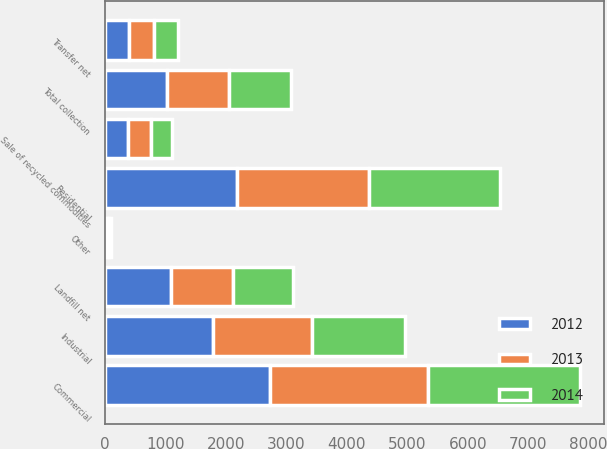<chart> <loc_0><loc_0><loc_500><loc_500><stacked_bar_chart><ecel><fcel>Residential<fcel>Commercial<fcel>Industrial<fcel>Other<fcel>Total collection<fcel>Transfer net<fcel>Landfill net<fcel>Sale of recycled commodities<nl><fcel>2012<fcel>2193.6<fcel>2723.3<fcel>1784<fcel>37.2<fcel>1025<fcel>408.2<fcel>1086.4<fcel>390.8<nl><fcel>2013<fcel>2175.5<fcel>2616.9<fcel>1639.4<fcel>34.7<fcel>1025<fcel>406.6<fcel>1025<fcel>374.6<nl><fcel>2014<fcel>2155.7<fcel>2523.2<fcel>1544.2<fcel>33.4<fcel>1025<fcel>389.2<fcel>1000.8<fcel>349<nl></chart> 